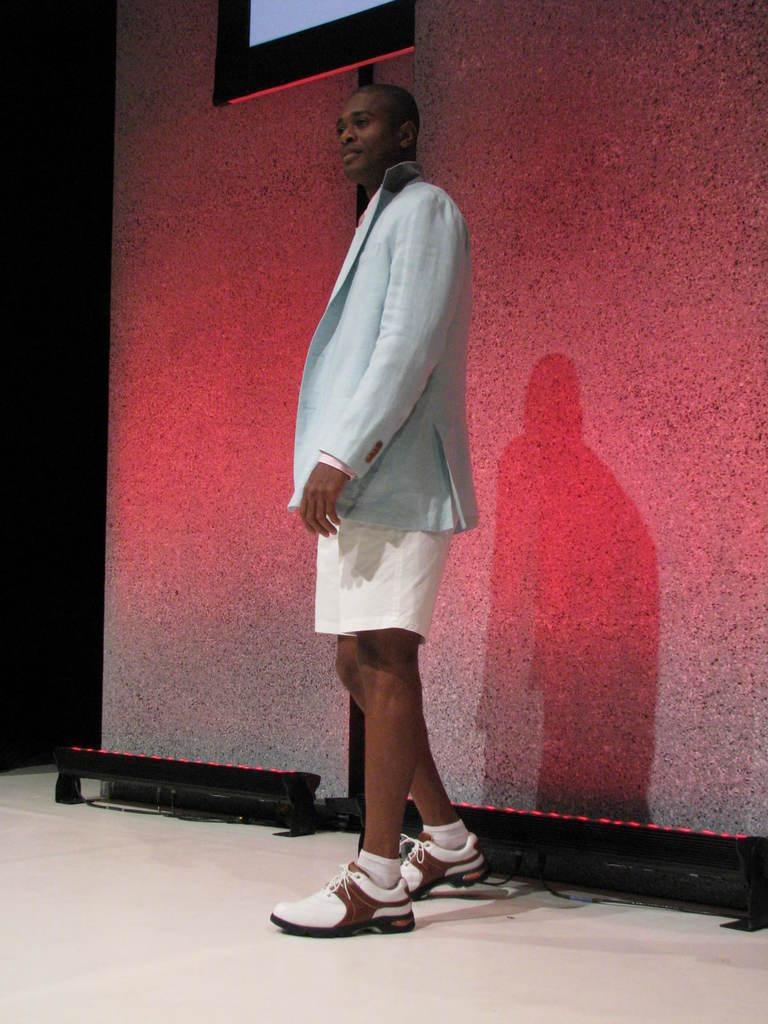How would you summarize this image in a sentence or two? Here we can see a person standing on the floor. In the background we can see a wall and a screen. 